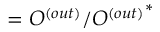<formula> <loc_0><loc_0><loc_500><loc_500>= O ^ { ( o u t ) } / { O ^ { ( o u t ) } } ^ { * }</formula> 